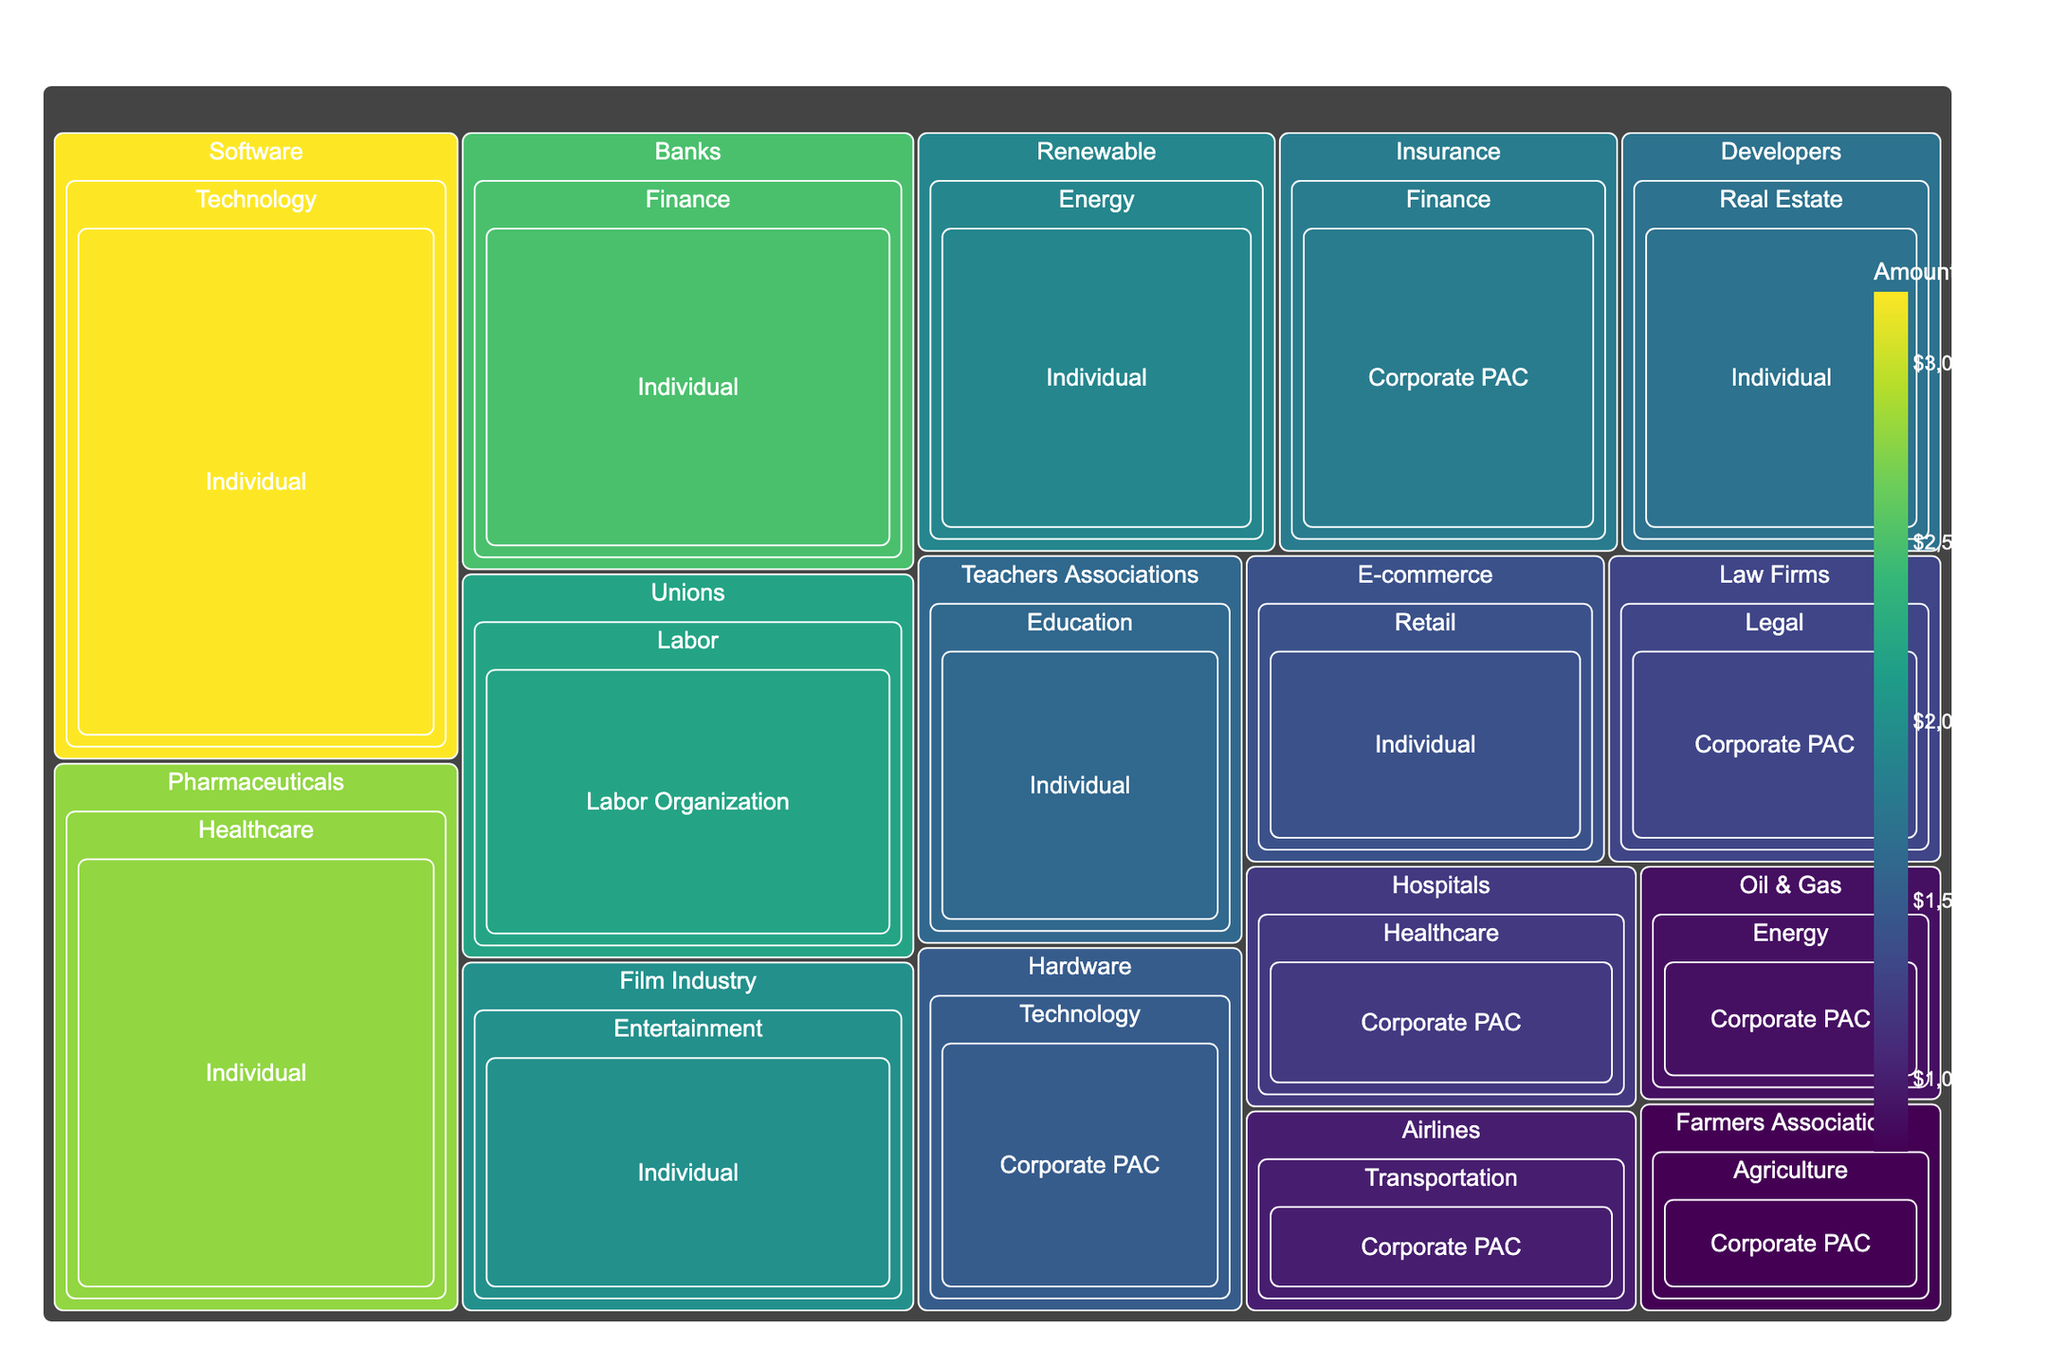What is the title of the treemap? The title of the treemap is positioned at the top of the plot and gives a concise summary of what the visualization represents. In this case, it's related to campaign contributions.
Answer: Campaign Contributions by Industry Sector and Donor Type Which Industry category received the highest amount of campaign contributions overall? By looking at the size of the rectangles, which visually represent the amount of contributions, the 'Technology' sector has the largest area.
Answer: Technology What is the color scale used in the treemap? The color scale is defined at the side of the treemap, showing the range and the associated palette used. Here, it’s a gradient from the 'Viridis' color scale.
Answer: Viridis How much did individual donors contribute to the Software industry? Navigate the treemap to find the 'Software' industry under the 'Technology' sector, and then see the contribution labeled as 'Individual'. The hover text or label will provide the exact amount.
Answer: $3,200,000 Compare the contributions from Corporate PACs in the Finance and Healthcare sectors. Which one is higher? Locate the Finance sector and note the contributions from Corporate PACs, then do the same for the Healthcare sector, and compare the amounts given. Finance has $1,800,000 and Healthcare has $1,200,000.
Answer: Finance What is the total amount of contributions by Labor Organizations? The only industry under the Labor sector is 'Unions'. The value for this is shown in the corresponding rectangle.
Answer: $2,200,000 Which donor type contributed the least to the Renewable industry within the Energy sector? Under the Energy sector, locate the Renewable industry. Since there is only one contribution type listed here, it is Individual.
Answer: Individual What’s the combined contribution amount from Individual donors in the Finance and Education sectors? Identify the contributions from Individual donors in both sectors: Finance (Banks, $2,500,000) and Education (Teachers Associations, $1,600,000). Sum them up: $2,500,000 + $1,600,000 = $4,100,000.
Answer: $4,100,000 Which industry has higher contributions from Individual donors, Film Industry or E-commerce? Compare the two industries under the Entertainment and Retail sectors respectively. Film Industry has $2,000,000, while E-commerce has $1,400,000.
Answer: Film Industry How do the contributions from Corporate PACs in Agriculture (Farmers Associations) compare to those in Transportation (Airlines)? Find the contribution values in the rectangles under the respective sectors. Agriculture (Farmers Associations) has $800,000 and Transportation (Airlines) has $1,000,000.
Answer: Transportation 